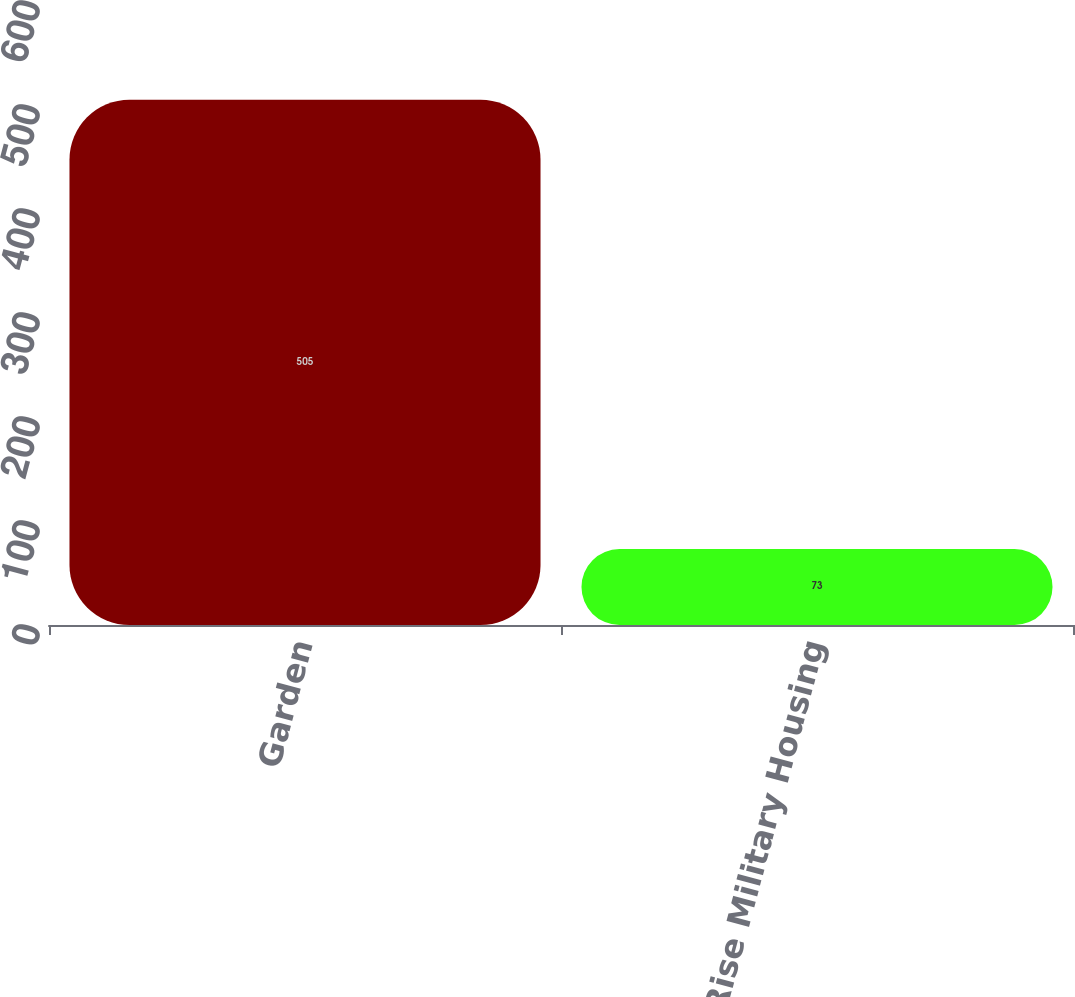<chart> <loc_0><loc_0><loc_500><loc_500><bar_chart><fcel>Garden<fcel>Mid/High-Rise Military Housing<nl><fcel>505<fcel>73<nl></chart> 